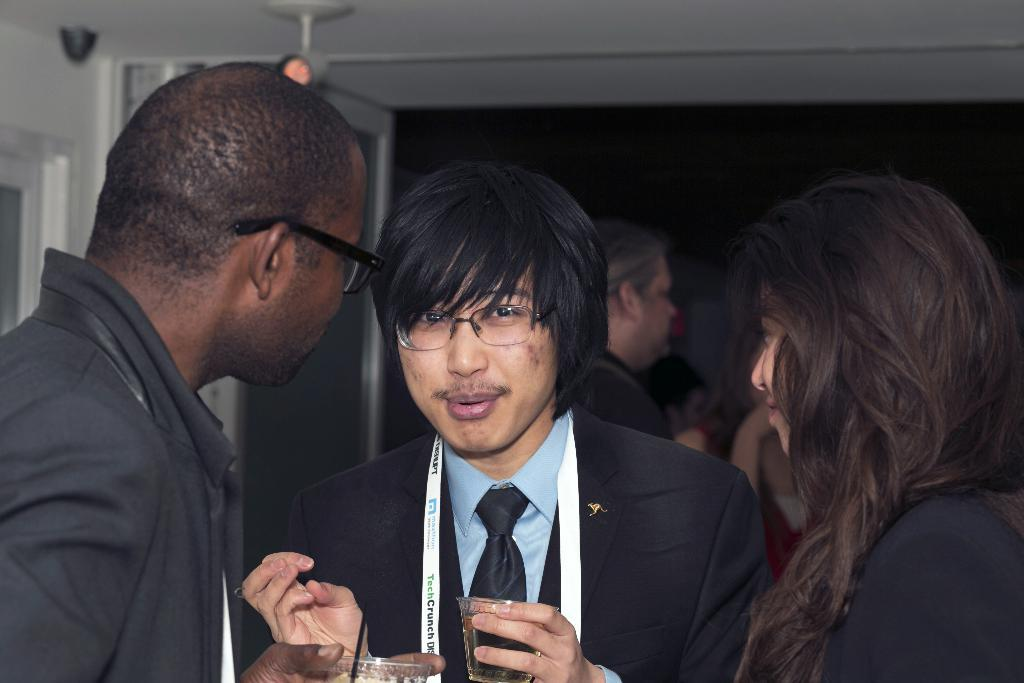What can be seen in the image? There are people standing in the image. Can you describe what the people are doing? There are men holding wine glasses in their hands. Is there a bomb visible in the image? No, there is no bomb present in the image. Can you describe how the men are stretching their arms in the image? The men are not stretching their arms in the image; they are holding wine glasses. 